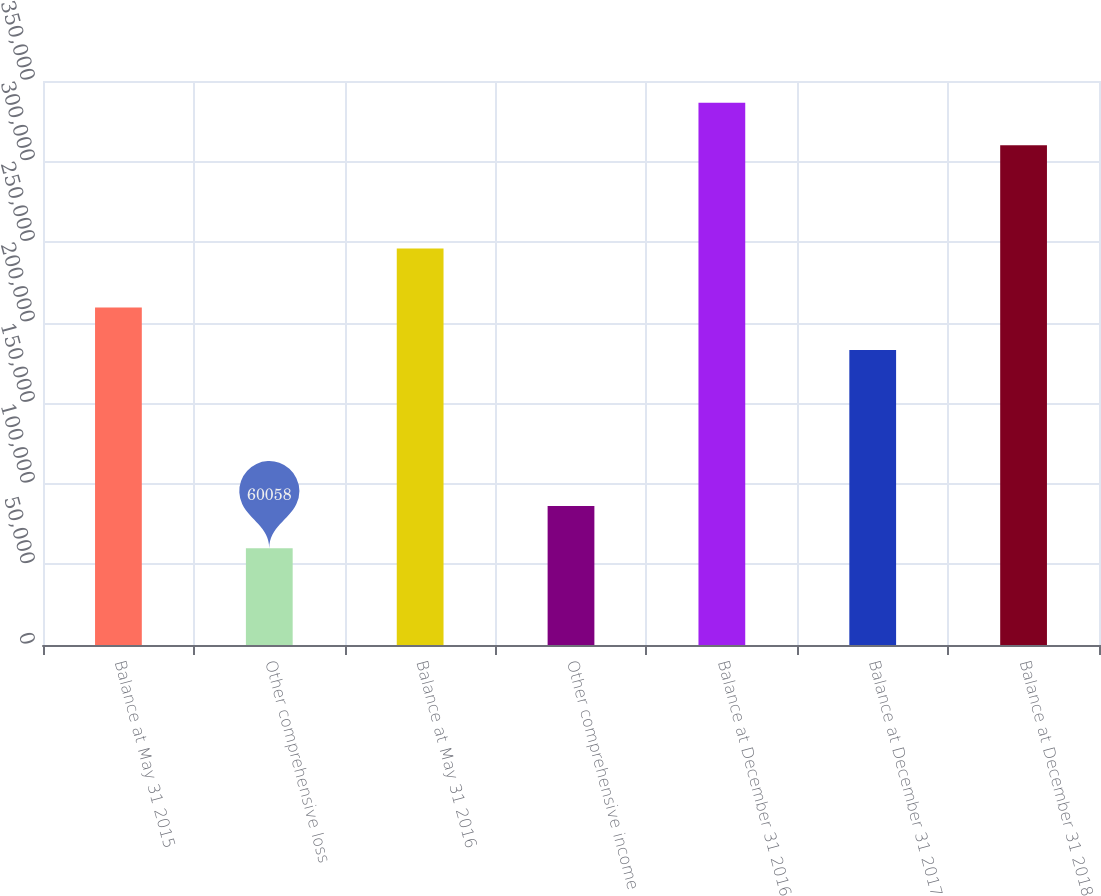<chart> <loc_0><loc_0><loc_500><loc_500><bar_chart><fcel>Balance at May 31 2015<fcel>Other comprehensive loss<fcel>Balance at May 31 2016<fcel>Other comprehensive income<fcel>Balance at December 31 2016<fcel>Balance at December 31 2017<fcel>Balance at December 31 2018<nl><fcel>209410<fcel>60058<fcel>246050<fcel>86323.9<fcel>336441<fcel>183144<fcel>310175<nl></chart> 